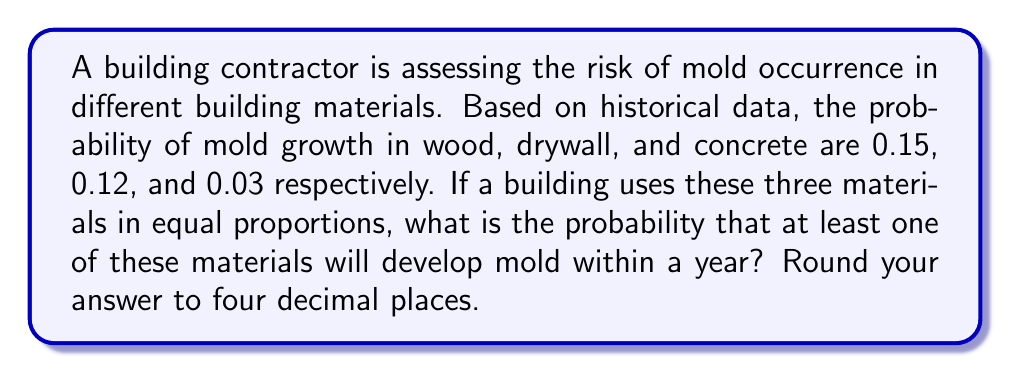Teach me how to tackle this problem. Let's approach this step-by-step:

1) First, we need to calculate the probability that none of the materials will develop mold. We can then subtract this from 1 to get the probability that at least one will develop mold.

2) The probability of no mold in wood is $1 - 0.15 = 0.85$
   The probability of no mold in drywall is $1 - 0.12 = 0.88$
   The probability of no mold in concrete is $1 - 0.03 = 0.97$

3) Since the materials are used in equal proportions and we assume independence, the probability of no mold in any of the materials is the product of these probabilities:

   $P(\text{no mold}) = 0.85 \times 0.88 \times 0.97 = 0.7259$

4) Therefore, the probability of mold in at least one material is:

   $P(\text{at least one mold}) = 1 - P(\text{no mold}) = 1 - 0.7259 = 0.2741$

5) Rounding to four decimal places:

   $0.2741 \approx 0.2741$
Answer: 0.2741 